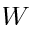<formula> <loc_0><loc_0><loc_500><loc_500>W</formula> 